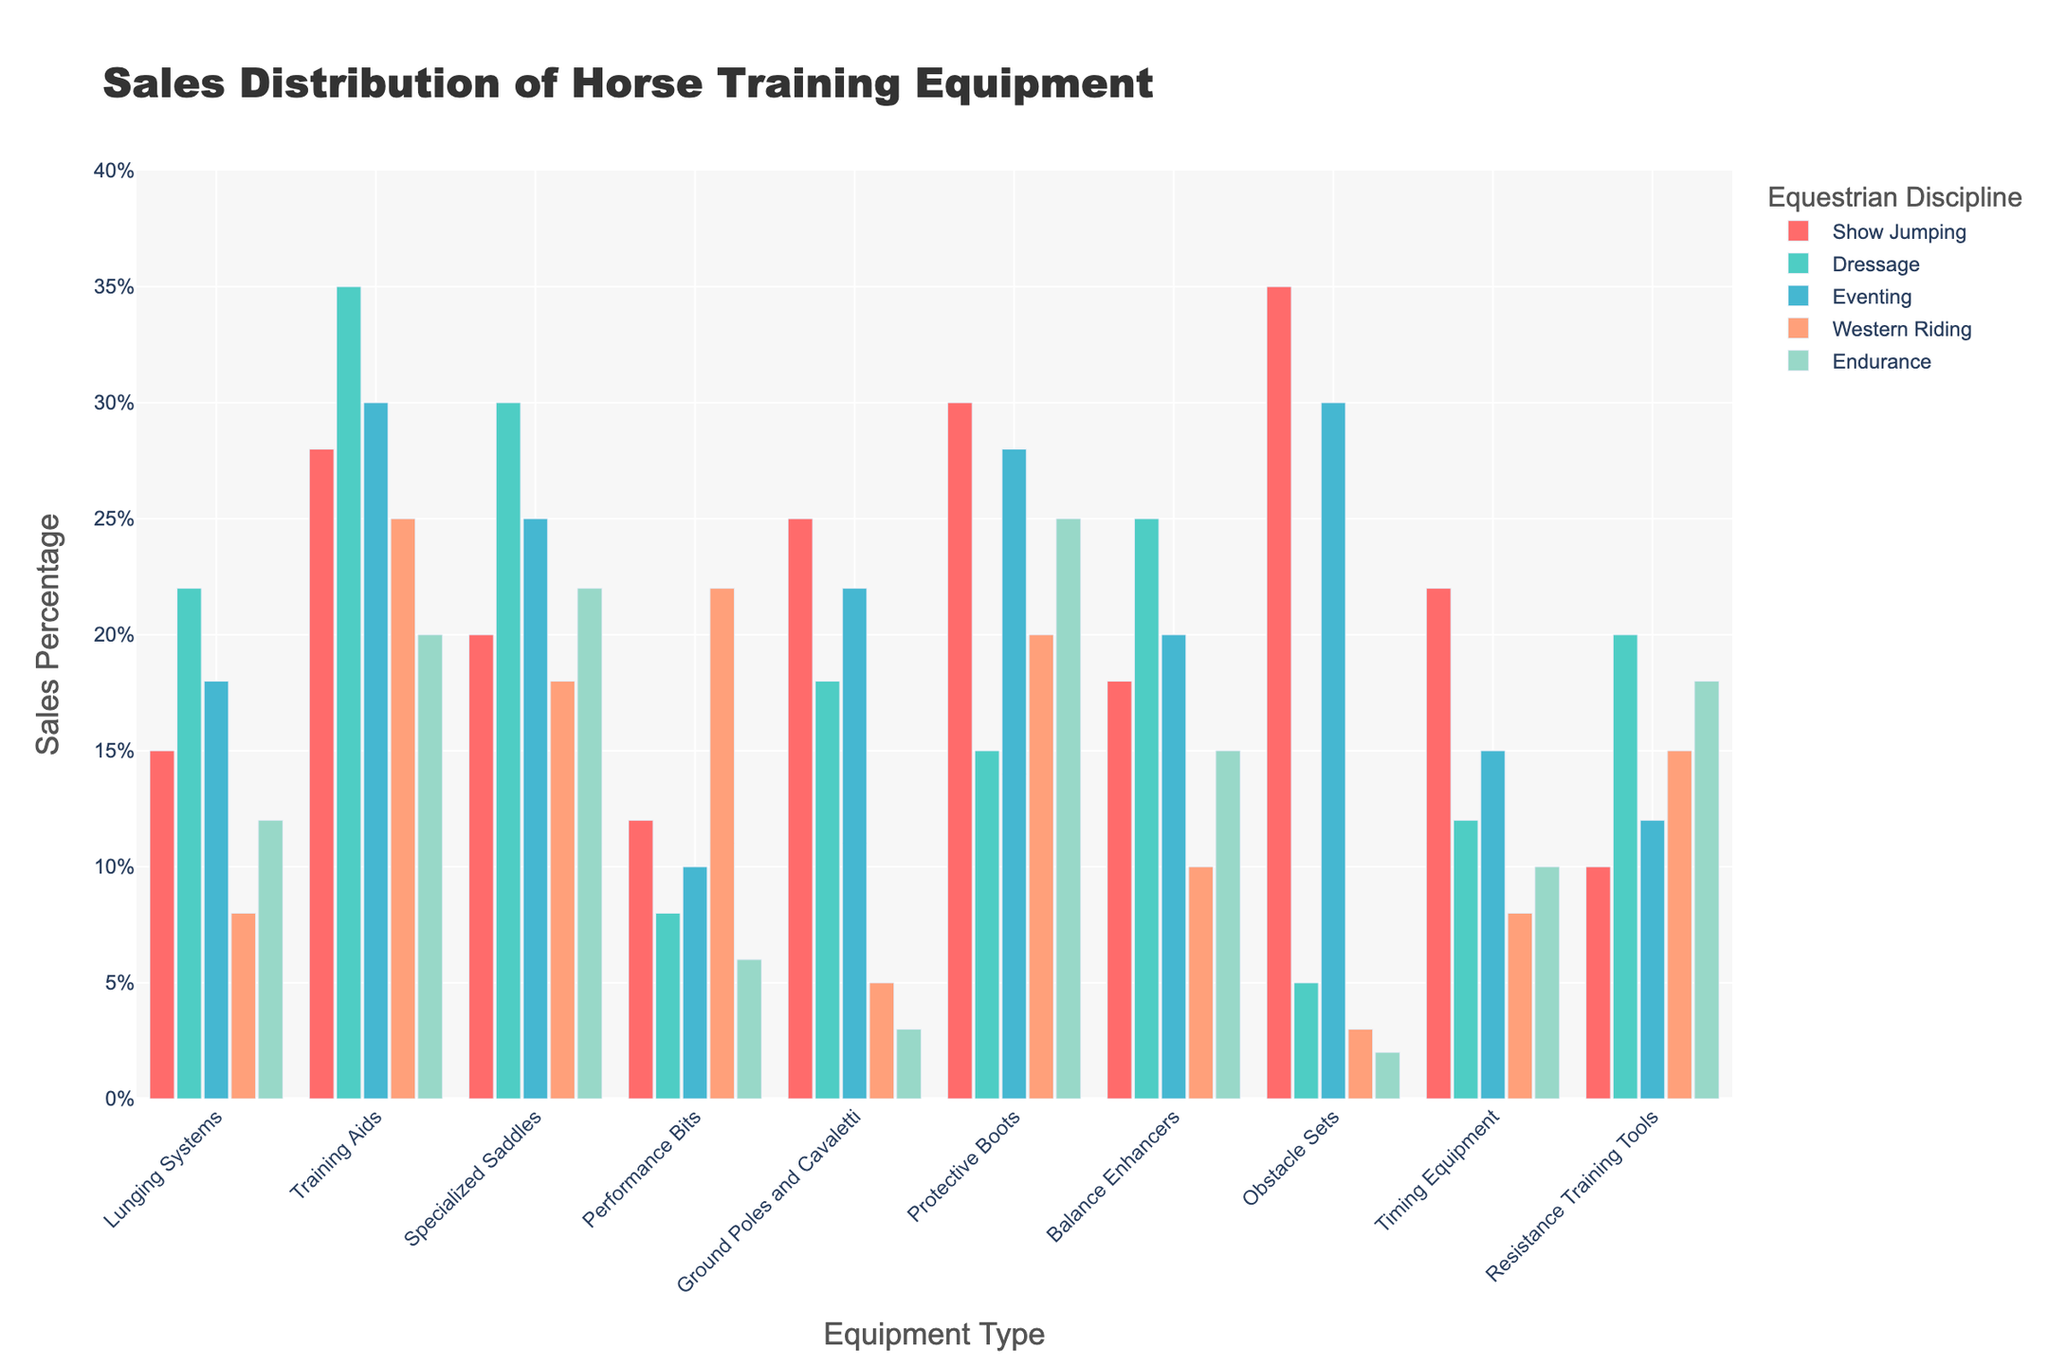What is the highest percentage of sales for Obstacle Sets among all disciplines? Look for the bar representing Obstacle Sets and compare the heights of the bars across all disciplines. The Show Jumping bar is the tallest, indicating the highest percentage.
Answer: 35% Which discipline has the least sales for Ground Poles and Cavaletti? Observe the bars for Ground Poles and Cavaletti across all disciplines. The Western Riding bar is the shortest, indicating the least sales.
Answer: Western Riding Compare the sales percentages of Lunging Systems in Dressage and Western Riding. Which one is higher, and by how much? Compare the bars for Lunging Systems in Dressage and Western Riding. Dressage has 22%, and Western Riding has 8%. The difference is 22% - 8% = 14%.
Answer: Dressage by 14% Among Training Aids, Specialized Saddles, and Performance Bits, which equipment type has the highest sales in Eventing? Observe the bars for Training Aids, Specialized Saddles, and Performance Bits in the Eventing category. Training Aids has the highest bar.
Answer: Training Aids What is the average percentage of sales for Timing Equipment across all disciplines? Sum the sales percentages of Timing Equipment for all disciplines and divide by the number of disciplines: (22 + 12 + 15 + 8 + 10) / 5 = 13.4%
Answer: 13.4% For which discipline is the difference between the highest and lowest sales percentages the greatest? Identify the range of sales for each discipline and find the maximum difference. Show Jumping ranges from 10% to 35% (25%), Dressage from 5% to 35% (30%), Eventing from 2% to 30% (28%), Western Riding from 3% to 25% (22%), and Endurance from 2% to 25% (23%). Dressage has the greatest difference.
Answer: Dressage Which equipment type has the highest total sales across all disciplines? Sum the sales percentages for each equipment type across all disciplines and find the maximum. Obstacle Sets: 75%, Lunging Systems: 75%, Training Aids: 138%, Specialized Saddles: 115%, Performance Bits: 64%, Ground Poles and Cavaletti: 73%, Protective Boots: 118%, Balance Enhancers: 88%, Timing Equipment: 67%, Resistance Training Tools: 75%. Training Aids has the highest total.
Answer: Training Aids How do sales of Protective Boots in Endurance compare to sales in Eventing and Dressage combined? Compare the bar heights: Endurance has 25%, Eventing has 28%, and Dressage has 15%. Combined Dressage and Eventing is 43% (28% + 15%).
Answer: Endurance is less by 18% 